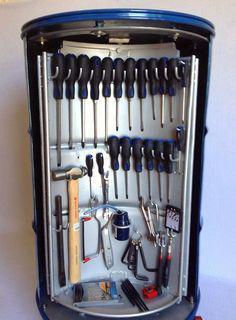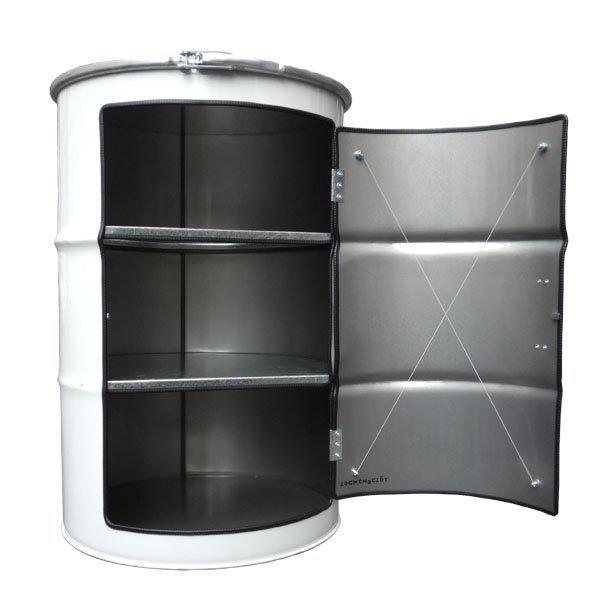The first image is the image on the left, the second image is the image on the right. Examine the images to the left and right. Is the description "there is an empty drum open so the inside is viewable" accurate? Answer yes or no. Yes. The first image is the image on the left, the second image is the image on the right. Evaluate the accuracy of this statement regarding the images: "The right image shows an empty barrel with a hinged opening, and the left image shows a tool-filled blue barrel with an open front.". Is it true? Answer yes or no. Yes. 